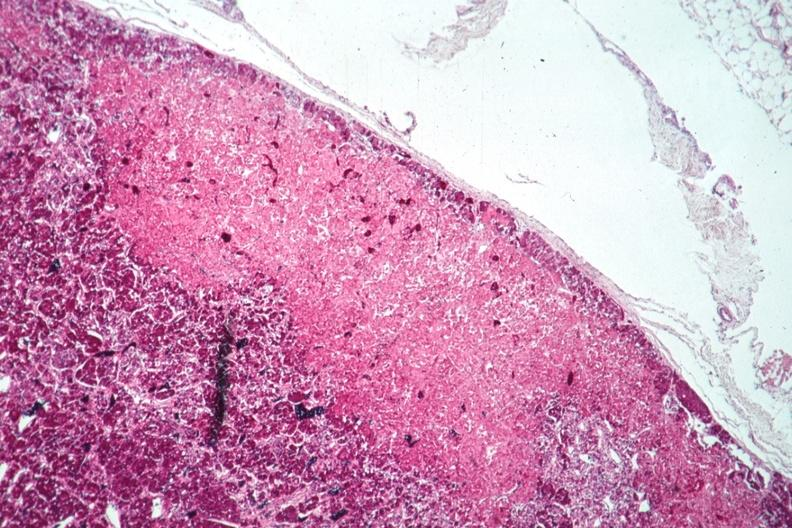does this image show well shown infarct?
Answer the question using a single word or phrase. Yes 